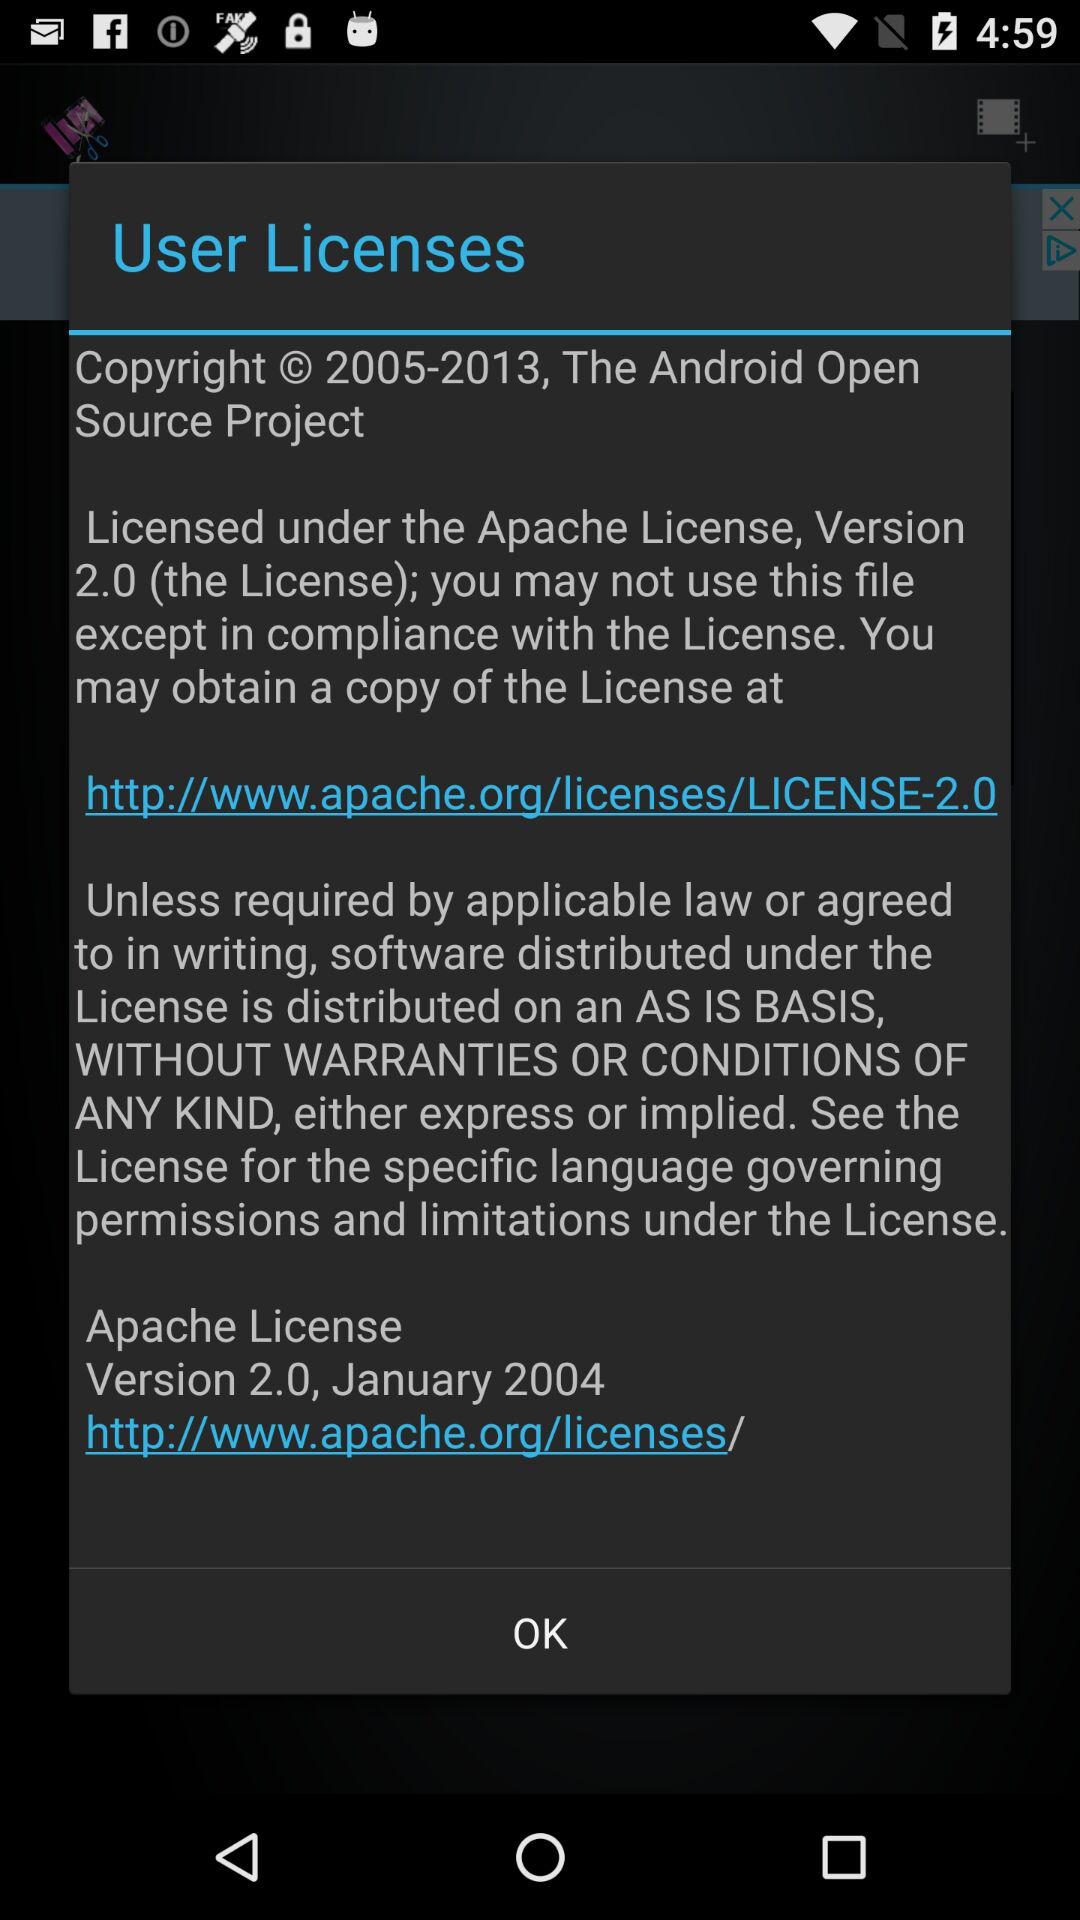What is the version of Android? The version is 2.0. 